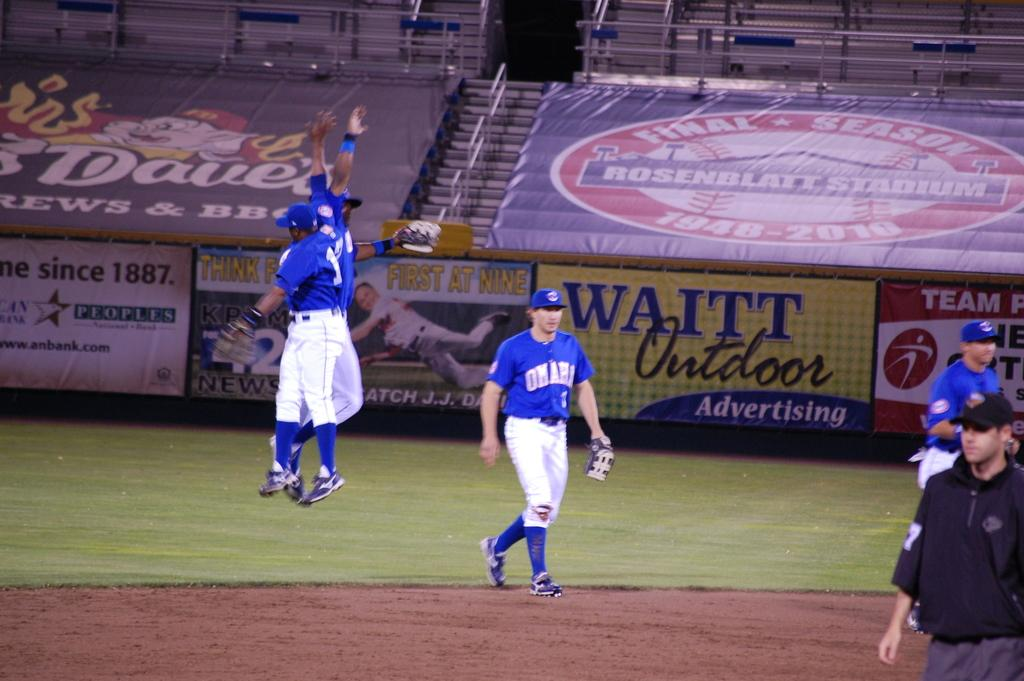<image>
Write a terse but informative summary of the picture. The Omaha players walk on the field at Rosenblatt Stadium in front of a sign for Waitt Outdoor Advertising. 